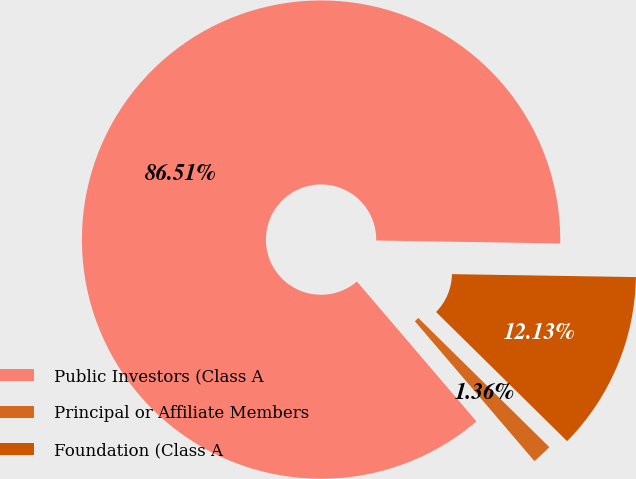Convert chart. <chart><loc_0><loc_0><loc_500><loc_500><pie_chart><fcel>Public Investors (Class A<fcel>Principal or Affiliate Members<fcel>Foundation (Class A<nl><fcel>86.51%<fcel>1.36%<fcel>12.13%<nl></chart> 